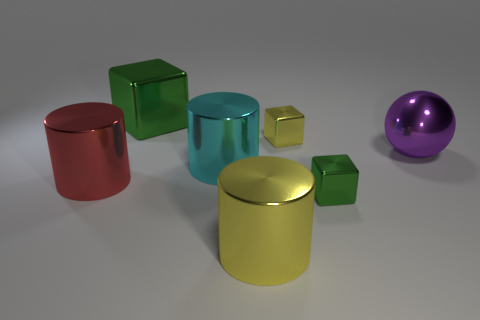How many metal cylinders have the same color as the large ball? None of the metal cylinders share the same color as the large purple ball, which stands alone in its hue compared to the varied colors of the cylinders. 